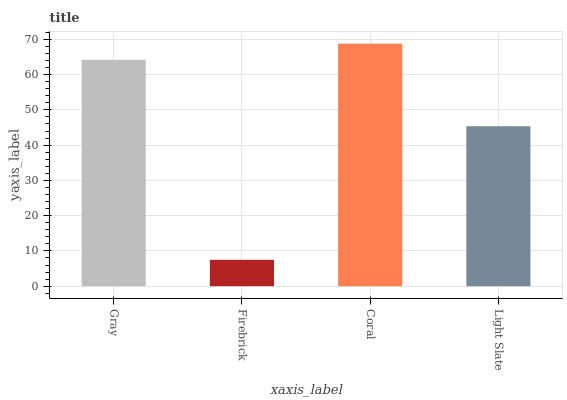Is Firebrick the minimum?
Answer yes or no. Yes. Is Coral the maximum?
Answer yes or no. Yes. Is Coral the minimum?
Answer yes or no. No. Is Firebrick the maximum?
Answer yes or no. No. Is Coral greater than Firebrick?
Answer yes or no. Yes. Is Firebrick less than Coral?
Answer yes or no. Yes. Is Firebrick greater than Coral?
Answer yes or no. No. Is Coral less than Firebrick?
Answer yes or no. No. Is Gray the high median?
Answer yes or no. Yes. Is Light Slate the low median?
Answer yes or no. Yes. Is Light Slate the high median?
Answer yes or no. No. Is Gray the low median?
Answer yes or no. No. 